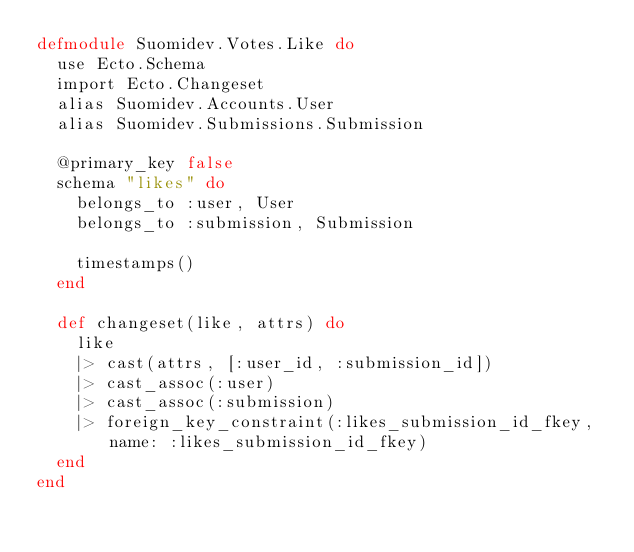Convert code to text. <code><loc_0><loc_0><loc_500><loc_500><_Elixir_>defmodule Suomidev.Votes.Like do
  use Ecto.Schema
  import Ecto.Changeset
  alias Suomidev.Accounts.User
  alias Suomidev.Submissions.Submission

  @primary_key false
  schema "likes" do
    belongs_to :user, User
    belongs_to :submission, Submission

    timestamps()
  end

  def changeset(like, attrs) do
    like
    |> cast(attrs, [:user_id, :submission_id])
    |> cast_assoc(:user)
    |> cast_assoc(:submission)
    |> foreign_key_constraint(:likes_submission_id_fkey, name: :likes_submission_id_fkey)
  end
end
</code> 